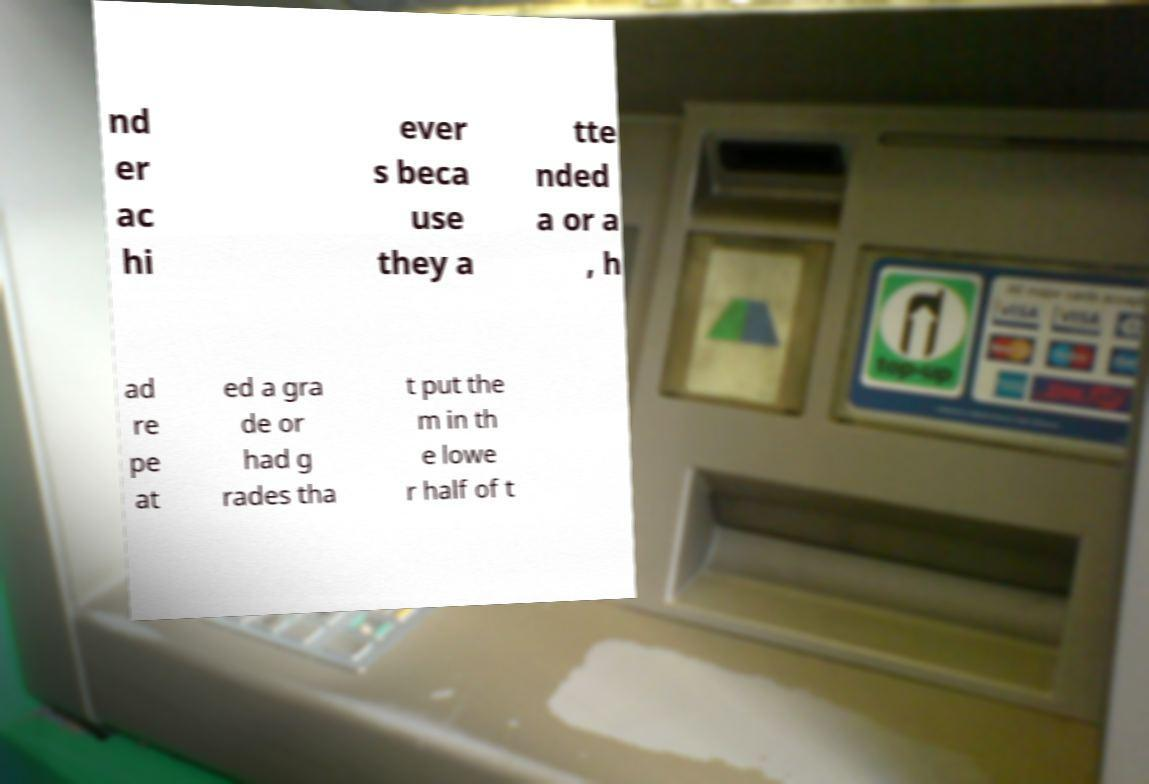Can you read and provide the text displayed in the image?This photo seems to have some interesting text. Can you extract and type it out for me? nd er ac hi ever s beca use they a tte nded a or a , h ad re pe at ed a gra de or had g rades tha t put the m in th e lowe r half of t 